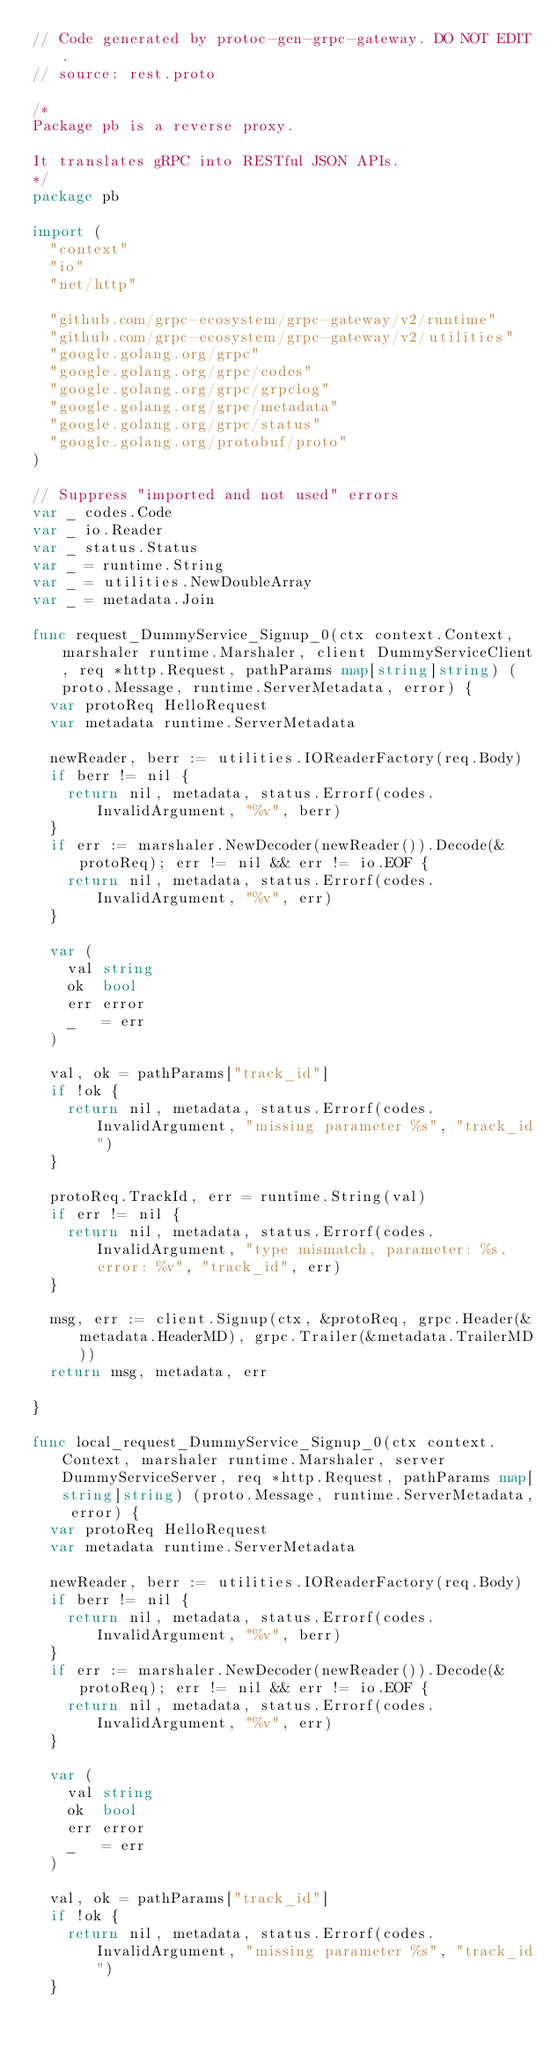<code> <loc_0><loc_0><loc_500><loc_500><_Go_>// Code generated by protoc-gen-grpc-gateway. DO NOT EDIT.
// source: rest.proto

/*
Package pb is a reverse proxy.

It translates gRPC into RESTful JSON APIs.
*/
package pb

import (
	"context"
	"io"
	"net/http"

	"github.com/grpc-ecosystem/grpc-gateway/v2/runtime"
	"github.com/grpc-ecosystem/grpc-gateway/v2/utilities"
	"google.golang.org/grpc"
	"google.golang.org/grpc/codes"
	"google.golang.org/grpc/grpclog"
	"google.golang.org/grpc/metadata"
	"google.golang.org/grpc/status"
	"google.golang.org/protobuf/proto"
)

// Suppress "imported and not used" errors
var _ codes.Code
var _ io.Reader
var _ status.Status
var _ = runtime.String
var _ = utilities.NewDoubleArray
var _ = metadata.Join

func request_DummyService_Signup_0(ctx context.Context, marshaler runtime.Marshaler, client DummyServiceClient, req *http.Request, pathParams map[string]string) (proto.Message, runtime.ServerMetadata, error) {
	var protoReq HelloRequest
	var metadata runtime.ServerMetadata

	newReader, berr := utilities.IOReaderFactory(req.Body)
	if berr != nil {
		return nil, metadata, status.Errorf(codes.InvalidArgument, "%v", berr)
	}
	if err := marshaler.NewDecoder(newReader()).Decode(&protoReq); err != nil && err != io.EOF {
		return nil, metadata, status.Errorf(codes.InvalidArgument, "%v", err)
	}

	var (
		val string
		ok  bool
		err error
		_   = err
	)

	val, ok = pathParams["track_id"]
	if !ok {
		return nil, metadata, status.Errorf(codes.InvalidArgument, "missing parameter %s", "track_id")
	}

	protoReq.TrackId, err = runtime.String(val)
	if err != nil {
		return nil, metadata, status.Errorf(codes.InvalidArgument, "type mismatch, parameter: %s, error: %v", "track_id", err)
	}

	msg, err := client.Signup(ctx, &protoReq, grpc.Header(&metadata.HeaderMD), grpc.Trailer(&metadata.TrailerMD))
	return msg, metadata, err

}

func local_request_DummyService_Signup_0(ctx context.Context, marshaler runtime.Marshaler, server DummyServiceServer, req *http.Request, pathParams map[string]string) (proto.Message, runtime.ServerMetadata, error) {
	var protoReq HelloRequest
	var metadata runtime.ServerMetadata

	newReader, berr := utilities.IOReaderFactory(req.Body)
	if berr != nil {
		return nil, metadata, status.Errorf(codes.InvalidArgument, "%v", berr)
	}
	if err := marshaler.NewDecoder(newReader()).Decode(&protoReq); err != nil && err != io.EOF {
		return nil, metadata, status.Errorf(codes.InvalidArgument, "%v", err)
	}

	var (
		val string
		ok  bool
		err error
		_   = err
	)

	val, ok = pathParams["track_id"]
	if !ok {
		return nil, metadata, status.Errorf(codes.InvalidArgument, "missing parameter %s", "track_id")
	}
</code> 